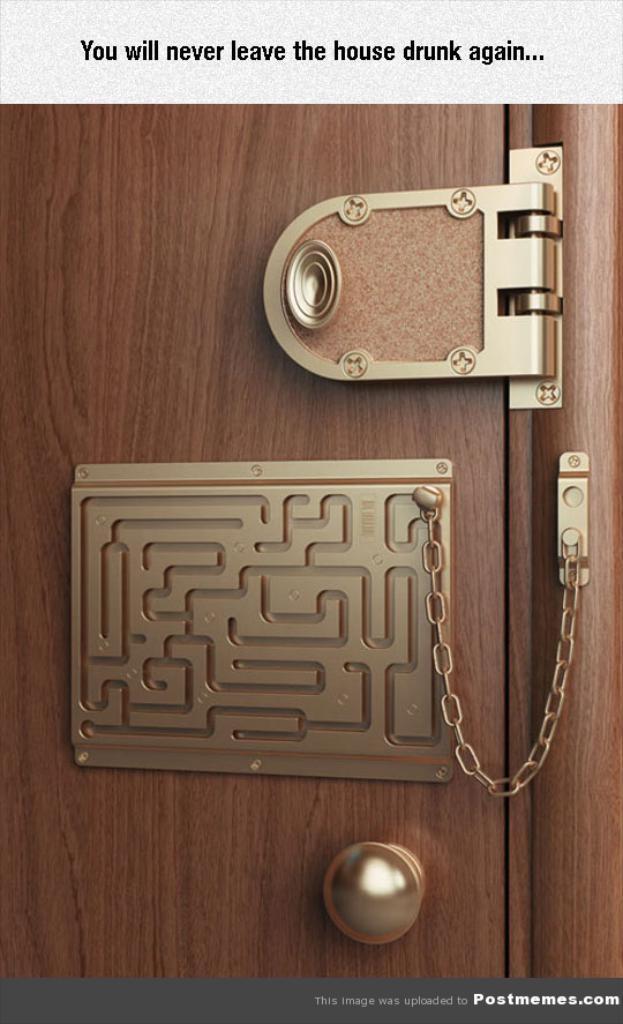Can you describe this image briefly? In this picture we can see a wooden object, door handle, chain, some objects and some text. 